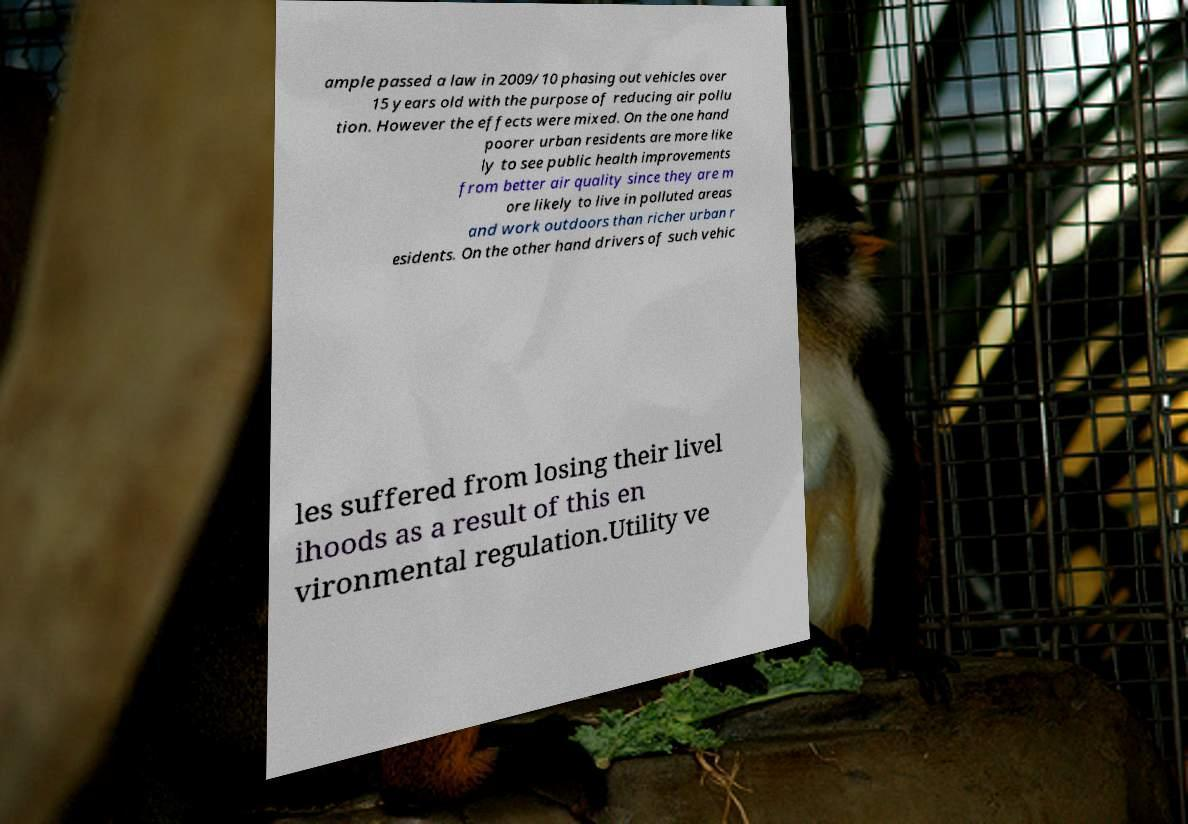Could you extract and type out the text from this image? ample passed a law in 2009/10 phasing out vehicles over 15 years old with the purpose of reducing air pollu tion. However the effects were mixed. On the one hand poorer urban residents are more like ly to see public health improvements from better air quality since they are m ore likely to live in polluted areas and work outdoors than richer urban r esidents. On the other hand drivers of such vehic les suffered from losing their livel ihoods as a result of this en vironmental regulation.Utility ve 